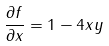<formula> <loc_0><loc_0><loc_500><loc_500>\frac { \partial f } { \partial x } = 1 - 4 x y</formula> 